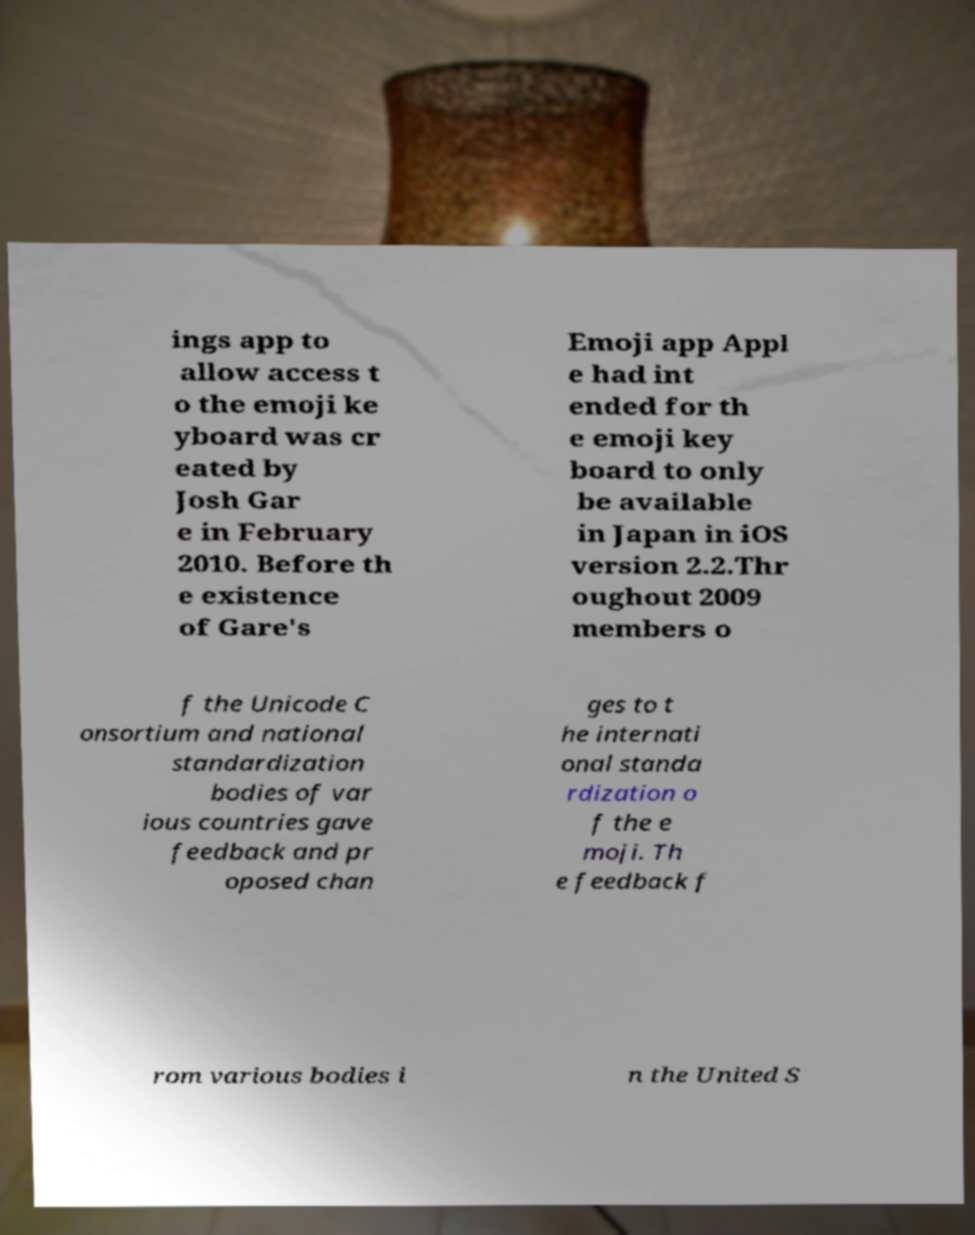Can you read and provide the text displayed in the image?This photo seems to have some interesting text. Can you extract and type it out for me? ings app to allow access t o the emoji ke yboard was cr eated by Josh Gar e in February 2010. Before th e existence of Gare's Emoji app Appl e had int ended for th e emoji key board to only be available in Japan in iOS version 2.2.Thr oughout 2009 members o f the Unicode C onsortium and national standardization bodies of var ious countries gave feedback and pr oposed chan ges to t he internati onal standa rdization o f the e moji. Th e feedback f rom various bodies i n the United S 